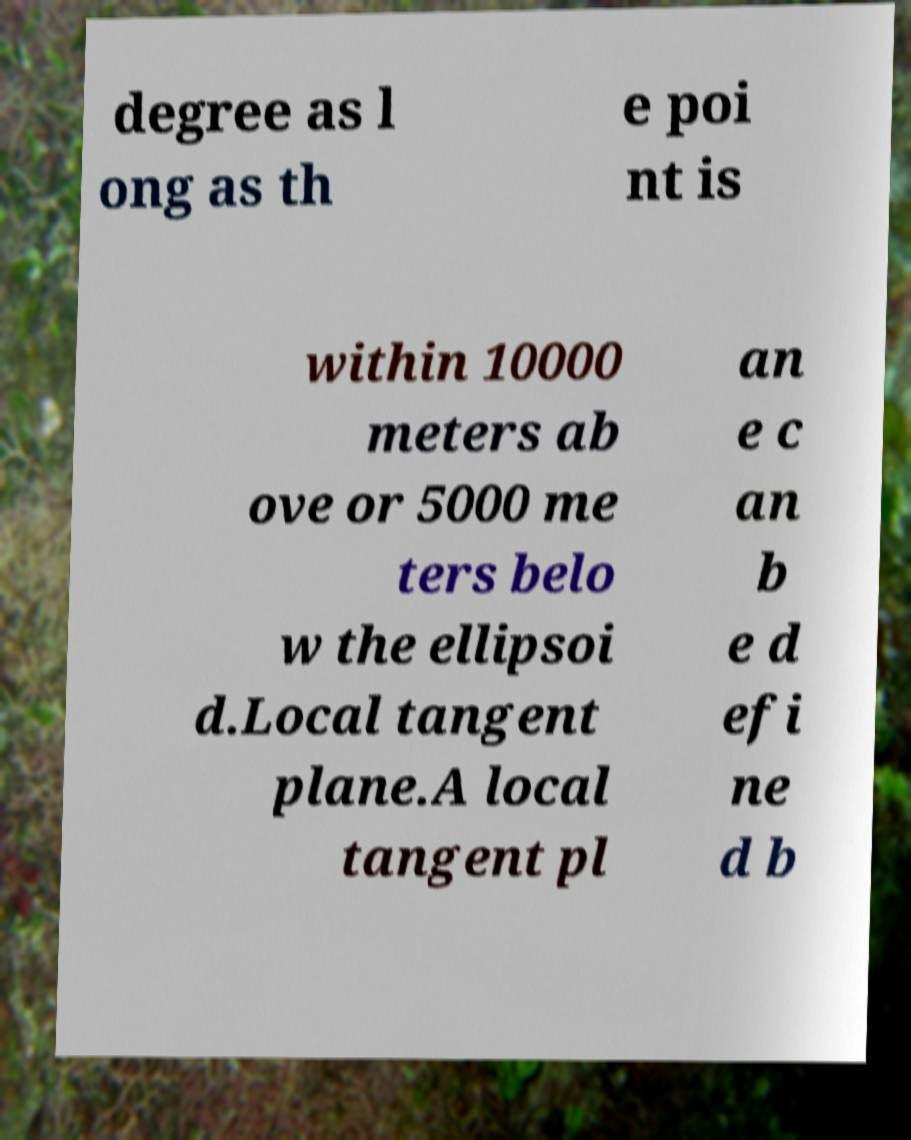For documentation purposes, I need the text within this image transcribed. Could you provide that? degree as l ong as th e poi nt is within 10000 meters ab ove or 5000 me ters belo w the ellipsoi d.Local tangent plane.A local tangent pl an e c an b e d efi ne d b 